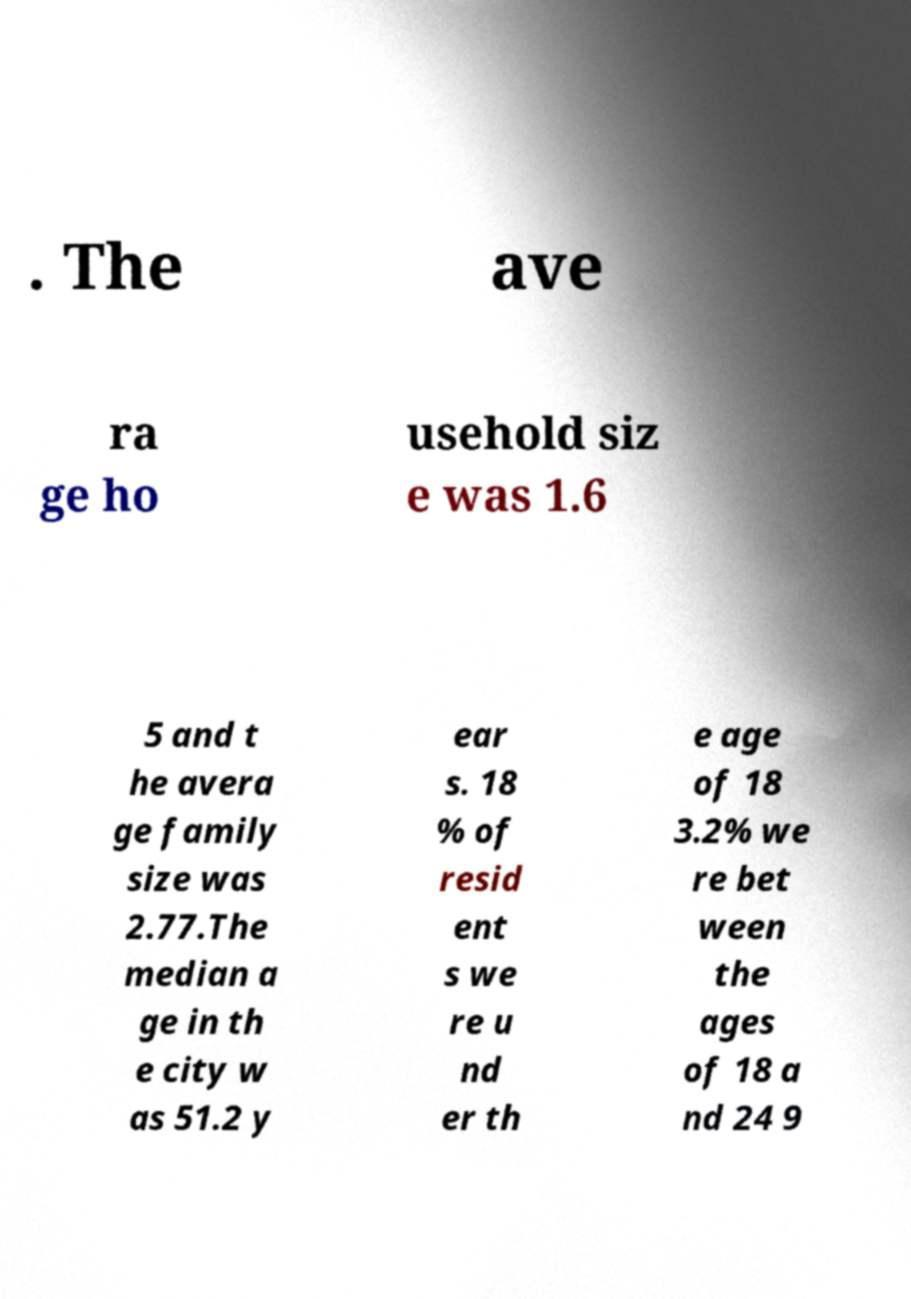Could you assist in decoding the text presented in this image and type it out clearly? . The ave ra ge ho usehold siz e was 1.6 5 and t he avera ge family size was 2.77.The median a ge in th e city w as 51.2 y ear s. 18 % of resid ent s we re u nd er th e age of 18 3.2% we re bet ween the ages of 18 a nd 24 9 